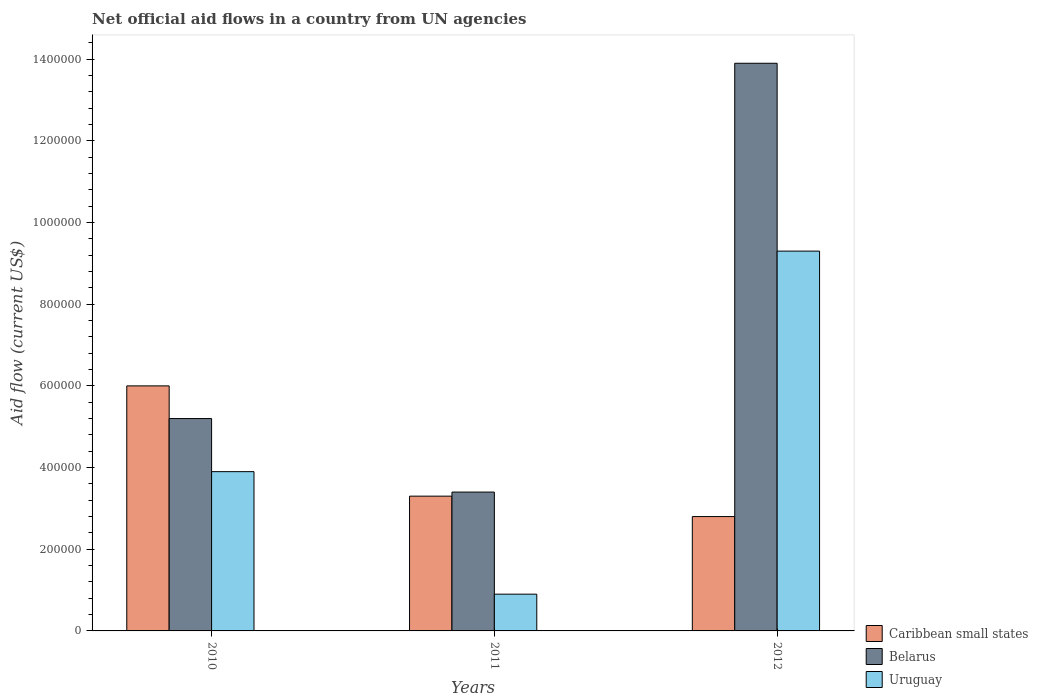How many different coloured bars are there?
Your response must be concise. 3. Are the number of bars per tick equal to the number of legend labels?
Provide a succinct answer. Yes. How many bars are there on the 1st tick from the left?
Offer a terse response. 3. What is the label of the 3rd group of bars from the left?
Provide a succinct answer. 2012. In how many cases, is the number of bars for a given year not equal to the number of legend labels?
Offer a very short reply. 0. What is the net official aid flow in Uruguay in 2012?
Make the answer very short. 9.30e+05. Across all years, what is the maximum net official aid flow in Caribbean small states?
Give a very brief answer. 6.00e+05. Across all years, what is the minimum net official aid flow in Uruguay?
Make the answer very short. 9.00e+04. In which year was the net official aid flow in Uruguay maximum?
Provide a succinct answer. 2012. In which year was the net official aid flow in Belarus minimum?
Your answer should be very brief. 2011. What is the total net official aid flow in Uruguay in the graph?
Your answer should be very brief. 1.41e+06. What is the difference between the net official aid flow in Caribbean small states in 2011 and that in 2012?
Provide a succinct answer. 5.00e+04. What is the difference between the net official aid flow in Uruguay in 2011 and the net official aid flow in Belarus in 2012?
Give a very brief answer. -1.30e+06. What is the average net official aid flow in Belarus per year?
Your answer should be compact. 7.50e+05. In the year 2010, what is the difference between the net official aid flow in Belarus and net official aid flow in Uruguay?
Your answer should be compact. 1.30e+05. In how many years, is the net official aid flow in Uruguay greater than 800000 US$?
Offer a terse response. 1. What is the ratio of the net official aid flow in Belarus in 2011 to that in 2012?
Offer a very short reply. 0.24. Is the difference between the net official aid flow in Belarus in 2010 and 2011 greater than the difference between the net official aid flow in Uruguay in 2010 and 2011?
Offer a terse response. No. What is the difference between the highest and the second highest net official aid flow in Caribbean small states?
Your response must be concise. 2.70e+05. What is the difference between the highest and the lowest net official aid flow in Belarus?
Make the answer very short. 1.05e+06. Is the sum of the net official aid flow in Uruguay in 2010 and 2011 greater than the maximum net official aid flow in Belarus across all years?
Make the answer very short. No. What does the 1st bar from the left in 2012 represents?
Your answer should be compact. Caribbean small states. What does the 2nd bar from the right in 2011 represents?
Keep it short and to the point. Belarus. Is it the case that in every year, the sum of the net official aid flow in Uruguay and net official aid flow in Caribbean small states is greater than the net official aid flow in Belarus?
Offer a terse response. No. How many bars are there?
Ensure brevity in your answer.  9. What is the difference between two consecutive major ticks on the Y-axis?
Offer a very short reply. 2.00e+05. Does the graph contain grids?
Your answer should be compact. No. How many legend labels are there?
Your answer should be very brief. 3. What is the title of the graph?
Give a very brief answer. Net official aid flows in a country from UN agencies. Does "Vanuatu" appear as one of the legend labels in the graph?
Your answer should be very brief. No. What is the Aid flow (current US$) in Caribbean small states in 2010?
Provide a succinct answer. 6.00e+05. What is the Aid flow (current US$) of Belarus in 2010?
Keep it short and to the point. 5.20e+05. What is the Aid flow (current US$) of Uruguay in 2010?
Offer a terse response. 3.90e+05. What is the Aid flow (current US$) of Caribbean small states in 2011?
Keep it short and to the point. 3.30e+05. What is the Aid flow (current US$) in Belarus in 2011?
Offer a very short reply. 3.40e+05. What is the Aid flow (current US$) in Caribbean small states in 2012?
Give a very brief answer. 2.80e+05. What is the Aid flow (current US$) in Belarus in 2012?
Keep it short and to the point. 1.39e+06. What is the Aid flow (current US$) of Uruguay in 2012?
Your answer should be very brief. 9.30e+05. Across all years, what is the maximum Aid flow (current US$) in Caribbean small states?
Offer a terse response. 6.00e+05. Across all years, what is the maximum Aid flow (current US$) of Belarus?
Your response must be concise. 1.39e+06. Across all years, what is the maximum Aid flow (current US$) of Uruguay?
Offer a very short reply. 9.30e+05. Across all years, what is the minimum Aid flow (current US$) in Belarus?
Your answer should be very brief. 3.40e+05. What is the total Aid flow (current US$) of Caribbean small states in the graph?
Offer a very short reply. 1.21e+06. What is the total Aid flow (current US$) of Belarus in the graph?
Keep it short and to the point. 2.25e+06. What is the total Aid flow (current US$) of Uruguay in the graph?
Give a very brief answer. 1.41e+06. What is the difference between the Aid flow (current US$) in Caribbean small states in 2010 and that in 2012?
Provide a succinct answer. 3.20e+05. What is the difference between the Aid flow (current US$) in Belarus in 2010 and that in 2012?
Keep it short and to the point. -8.70e+05. What is the difference between the Aid flow (current US$) in Uruguay in 2010 and that in 2012?
Provide a succinct answer. -5.40e+05. What is the difference between the Aid flow (current US$) in Caribbean small states in 2011 and that in 2012?
Provide a short and direct response. 5.00e+04. What is the difference between the Aid flow (current US$) in Belarus in 2011 and that in 2012?
Give a very brief answer. -1.05e+06. What is the difference between the Aid flow (current US$) in Uruguay in 2011 and that in 2012?
Give a very brief answer. -8.40e+05. What is the difference between the Aid flow (current US$) in Caribbean small states in 2010 and the Aid flow (current US$) in Uruguay in 2011?
Offer a terse response. 5.10e+05. What is the difference between the Aid flow (current US$) of Caribbean small states in 2010 and the Aid flow (current US$) of Belarus in 2012?
Make the answer very short. -7.90e+05. What is the difference between the Aid flow (current US$) of Caribbean small states in 2010 and the Aid flow (current US$) of Uruguay in 2012?
Your response must be concise. -3.30e+05. What is the difference between the Aid flow (current US$) in Belarus in 2010 and the Aid flow (current US$) in Uruguay in 2012?
Your answer should be compact. -4.10e+05. What is the difference between the Aid flow (current US$) of Caribbean small states in 2011 and the Aid flow (current US$) of Belarus in 2012?
Give a very brief answer. -1.06e+06. What is the difference between the Aid flow (current US$) in Caribbean small states in 2011 and the Aid flow (current US$) in Uruguay in 2012?
Your response must be concise. -6.00e+05. What is the difference between the Aid flow (current US$) in Belarus in 2011 and the Aid flow (current US$) in Uruguay in 2012?
Provide a succinct answer. -5.90e+05. What is the average Aid flow (current US$) in Caribbean small states per year?
Provide a short and direct response. 4.03e+05. What is the average Aid flow (current US$) in Belarus per year?
Offer a terse response. 7.50e+05. In the year 2010, what is the difference between the Aid flow (current US$) of Caribbean small states and Aid flow (current US$) of Belarus?
Your response must be concise. 8.00e+04. In the year 2010, what is the difference between the Aid flow (current US$) in Caribbean small states and Aid flow (current US$) in Uruguay?
Offer a terse response. 2.10e+05. In the year 2011, what is the difference between the Aid flow (current US$) of Caribbean small states and Aid flow (current US$) of Uruguay?
Give a very brief answer. 2.40e+05. In the year 2012, what is the difference between the Aid flow (current US$) of Caribbean small states and Aid flow (current US$) of Belarus?
Offer a terse response. -1.11e+06. In the year 2012, what is the difference between the Aid flow (current US$) of Caribbean small states and Aid flow (current US$) of Uruguay?
Your answer should be compact. -6.50e+05. What is the ratio of the Aid flow (current US$) of Caribbean small states in 2010 to that in 2011?
Make the answer very short. 1.82. What is the ratio of the Aid flow (current US$) of Belarus in 2010 to that in 2011?
Your answer should be compact. 1.53. What is the ratio of the Aid flow (current US$) of Uruguay in 2010 to that in 2011?
Offer a terse response. 4.33. What is the ratio of the Aid flow (current US$) of Caribbean small states in 2010 to that in 2012?
Make the answer very short. 2.14. What is the ratio of the Aid flow (current US$) of Belarus in 2010 to that in 2012?
Your answer should be compact. 0.37. What is the ratio of the Aid flow (current US$) of Uruguay in 2010 to that in 2012?
Provide a short and direct response. 0.42. What is the ratio of the Aid flow (current US$) of Caribbean small states in 2011 to that in 2012?
Your answer should be very brief. 1.18. What is the ratio of the Aid flow (current US$) of Belarus in 2011 to that in 2012?
Give a very brief answer. 0.24. What is the ratio of the Aid flow (current US$) in Uruguay in 2011 to that in 2012?
Offer a very short reply. 0.1. What is the difference between the highest and the second highest Aid flow (current US$) of Belarus?
Offer a terse response. 8.70e+05. What is the difference between the highest and the second highest Aid flow (current US$) of Uruguay?
Keep it short and to the point. 5.40e+05. What is the difference between the highest and the lowest Aid flow (current US$) of Belarus?
Offer a very short reply. 1.05e+06. What is the difference between the highest and the lowest Aid flow (current US$) of Uruguay?
Offer a very short reply. 8.40e+05. 